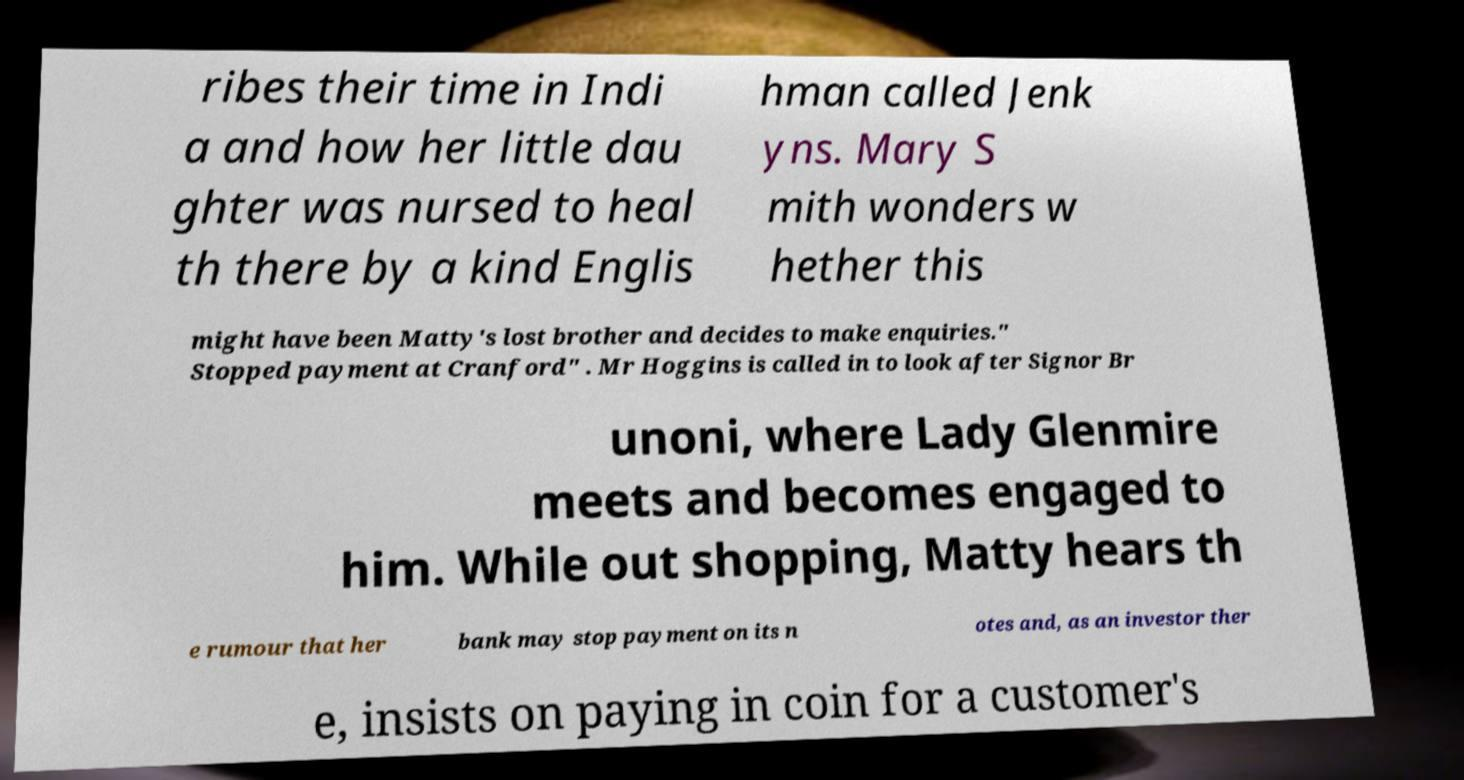I need the written content from this picture converted into text. Can you do that? ribes their time in Indi a and how her little dau ghter was nursed to heal th there by a kind Englis hman called Jenk yns. Mary S mith wonders w hether this might have been Matty's lost brother and decides to make enquiries." Stopped payment at Cranford" . Mr Hoggins is called in to look after Signor Br unoni, where Lady Glenmire meets and becomes engaged to him. While out shopping, Matty hears th e rumour that her bank may stop payment on its n otes and, as an investor ther e, insists on paying in coin for a customer's 